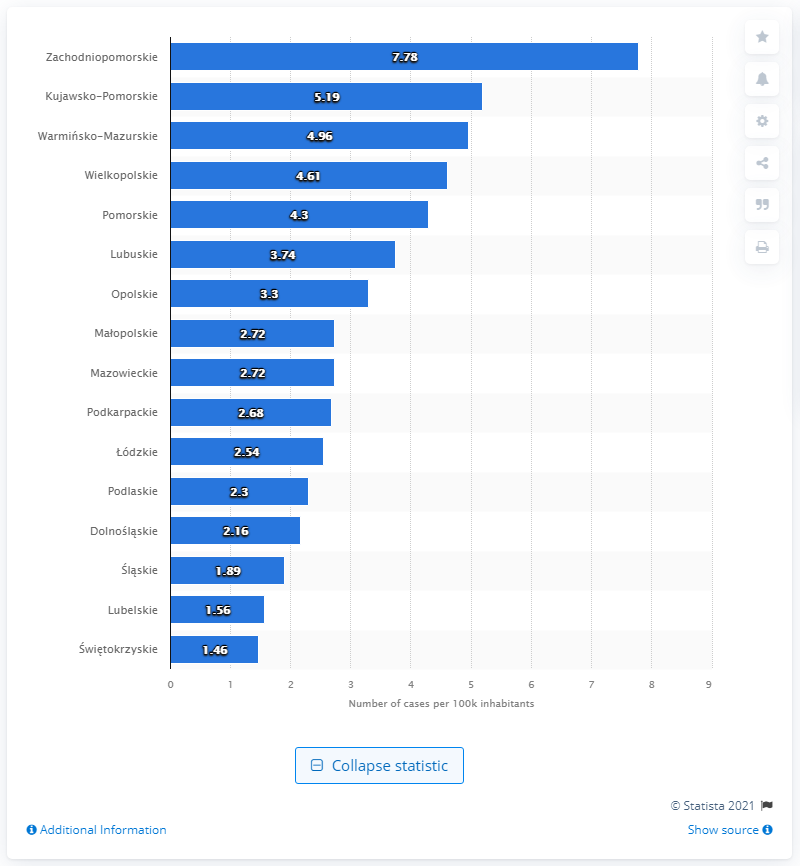Give some essential details in this illustration. The highest rate of infection per 10,000 inhabitants is found in Zachodniopomorskie. 